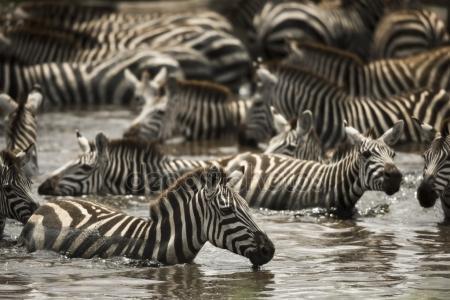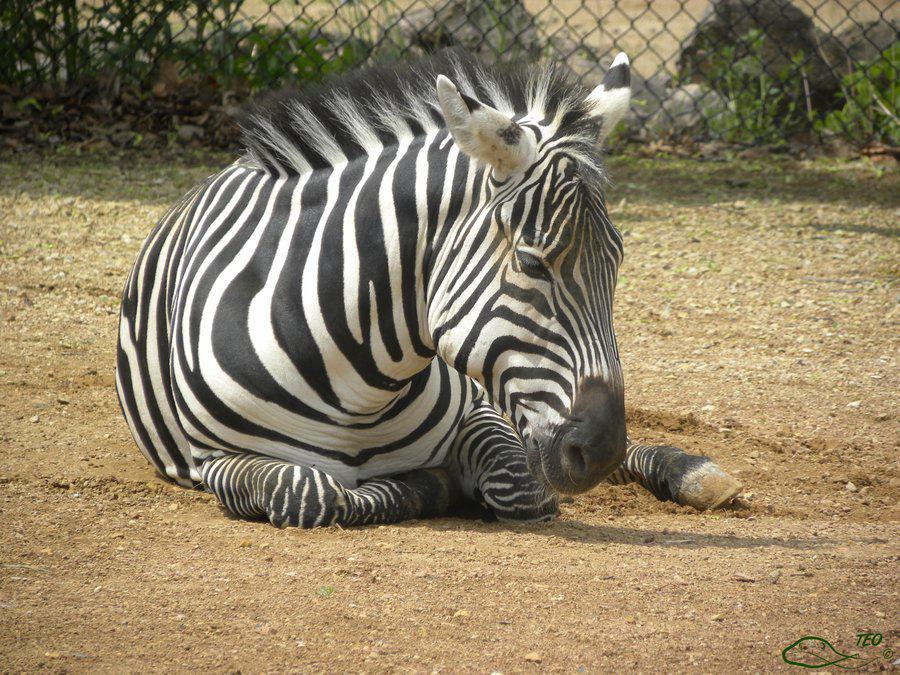The first image is the image on the left, the second image is the image on the right. Considering the images on both sides, is "Each image shows at least two zebra standing facing toward the center, one with its head over the back of the other." valid? Answer yes or no. No. The first image is the image on the left, the second image is the image on the right. Considering the images on both sides, is "The left and right image contains a total of five zebras." valid? Answer yes or no. No. 